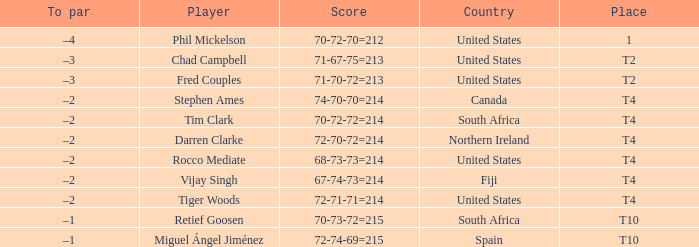What country is Chad Campbell from? United States. Can you give me this table as a dict? {'header': ['To par', 'Player', 'Score', 'Country', 'Place'], 'rows': [['–4', 'Phil Mickelson', '70-72-70=212', 'United States', '1'], ['–3', 'Chad Campbell', '71-67-75=213', 'United States', 'T2'], ['–3', 'Fred Couples', '71-70-72=213', 'United States', 'T2'], ['–2', 'Stephen Ames', '74-70-70=214', 'Canada', 'T4'], ['–2', 'Tim Clark', '70-72-72=214', 'South Africa', 'T4'], ['–2', 'Darren Clarke', '72-70-72=214', 'Northern Ireland', 'T4'], ['–2', 'Rocco Mediate', '68-73-73=214', 'United States', 'T4'], ['–2', 'Vijay Singh', '67-74-73=214', 'Fiji', 'T4'], ['–2', 'Tiger Woods', '72-71-71=214', 'United States', 'T4'], ['–1', 'Retief Goosen', '70-73-72=215', 'South Africa', 'T10'], ['–1', 'Miguel Ángel Jiménez', '72-74-69=215', 'Spain', 'T10']]} 